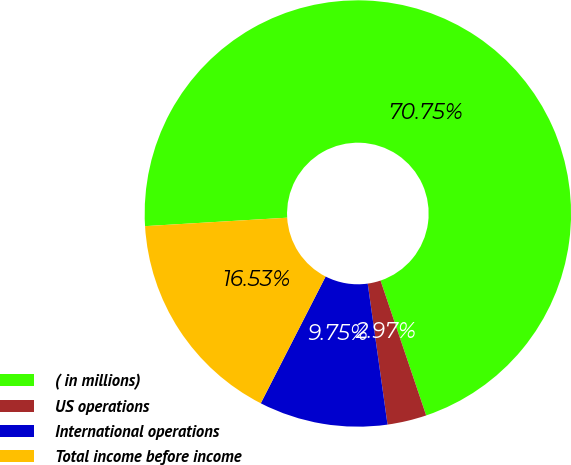<chart> <loc_0><loc_0><loc_500><loc_500><pie_chart><fcel>( in millions)<fcel>US operations<fcel>International operations<fcel>Total income before income<nl><fcel>70.76%<fcel>2.97%<fcel>9.75%<fcel>16.53%<nl></chart> 